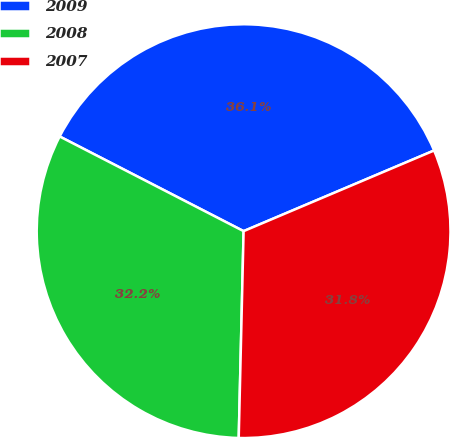<chart> <loc_0><loc_0><loc_500><loc_500><pie_chart><fcel>2009<fcel>2008<fcel>2007<nl><fcel>36.06%<fcel>32.19%<fcel>31.75%<nl></chart> 